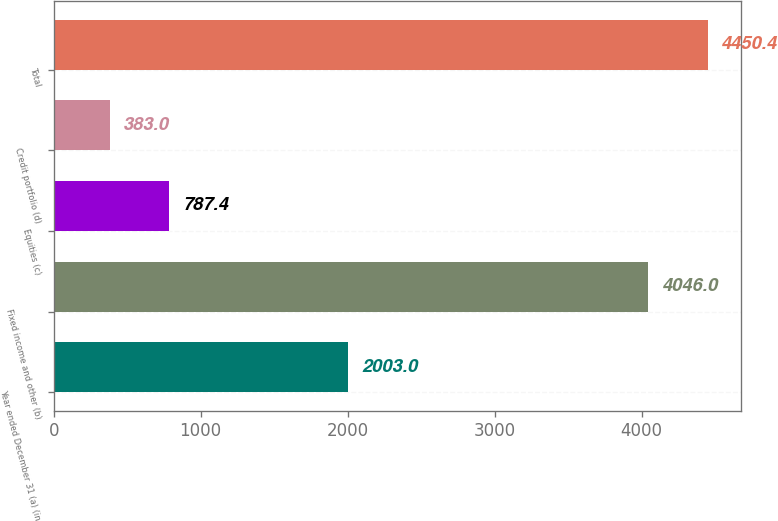Convert chart to OTSL. <chart><loc_0><loc_0><loc_500><loc_500><bar_chart><fcel>Year ended December 31 (a) (in<fcel>Fixed income and other (b)<fcel>Equities (c)<fcel>Credit portfolio (d)<fcel>Total<nl><fcel>2003<fcel>4046<fcel>787.4<fcel>383<fcel>4450.4<nl></chart> 